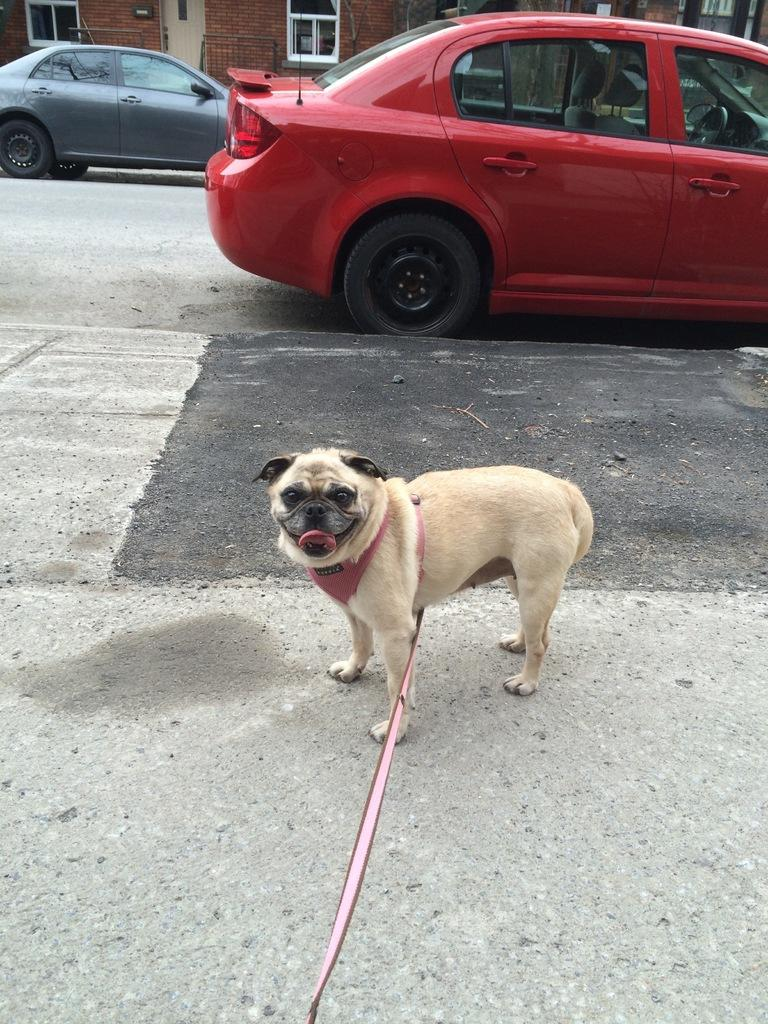What is in the foreground of the image? There is a road in the foreground of the image. What can be seen in the middle of the image? There is a dog in the middle of the image. Does the dog have any accessories? Yes, the dog has a belt. How many cars are visible in the image? There are two cars visible in the image. Where is the sponge located in the image? There is no sponge present in the image. What type of nest can be seen in the image? There is no nest present in the image. 